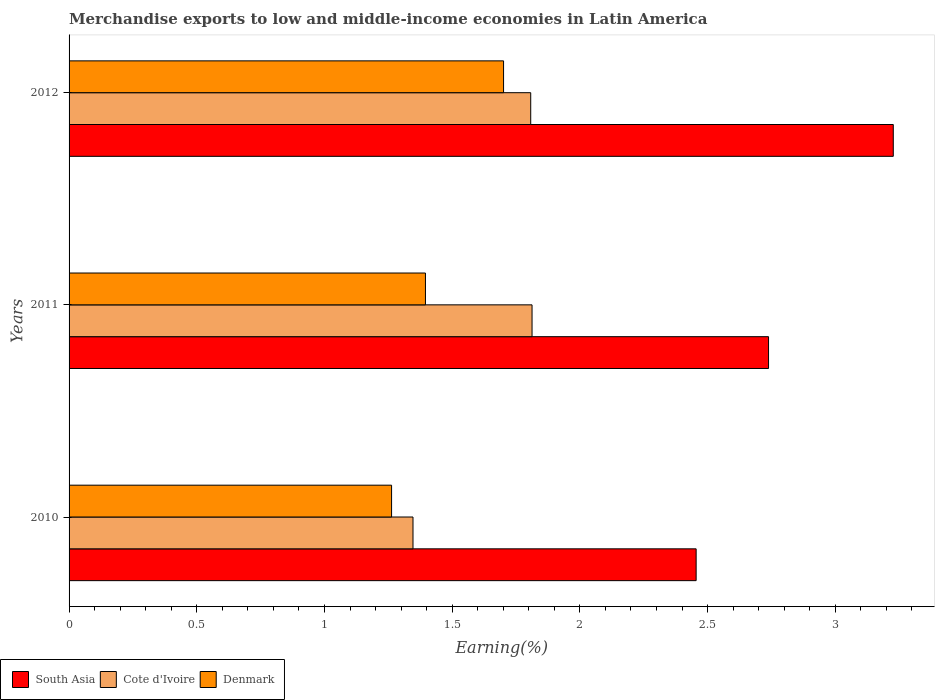How many groups of bars are there?
Your response must be concise. 3. Are the number of bars on each tick of the Y-axis equal?
Make the answer very short. Yes. How many bars are there on the 3rd tick from the top?
Provide a short and direct response. 3. How many bars are there on the 1st tick from the bottom?
Your response must be concise. 3. What is the percentage of amount earned from merchandise exports in South Asia in 2011?
Offer a terse response. 2.74. Across all years, what is the maximum percentage of amount earned from merchandise exports in South Asia?
Offer a terse response. 3.23. Across all years, what is the minimum percentage of amount earned from merchandise exports in Denmark?
Your response must be concise. 1.26. In which year was the percentage of amount earned from merchandise exports in South Asia maximum?
Your answer should be compact. 2012. What is the total percentage of amount earned from merchandise exports in Cote d'Ivoire in the graph?
Offer a terse response. 4.97. What is the difference between the percentage of amount earned from merchandise exports in South Asia in 2010 and that in 2012?
Provide a short and direct response. -0.77. What is the difference between the percentage of amount earned from merchandise exports in South Asia in 2011 and the percentage of amount earned from merchandise exports in Cote d'Ivoire in 2012?
Keep it short and to the point. 0.93. What is the average percentage of amount earned from merchandise exports in South Asia per year?
Your response must be concise. 2.81. In the year 2012, what is the difference between the percentage of amount earned from merchandise exports in Cote d'Ivoire and percentage of amount earned from merchandise exports in South Asia?
Offer a terse response. -1.42. In how many years, is the percentage of amount earned from merchandise exports in South Asia greater than 2 %?
Provide a succinct answer. 3. What is the ratio of the percentage of amount earned from merchandise exports in South Asia in 2011 to that in 2012?
Keep it short and to the point. 0.85. What is the difference between the highest and the second highest percentage of amount earned from merchandise exports in Denmark?
Your answer should be very brief. 0.31. What is the difference between the highest and the lowest percentage of amount earned from merchandise exports in South Asia?
Your answer should be very brief. 0.77. Is the sum of the percentage of amount earned from merchandise exports in Cote d'Ivoire in 2011 and 2012 greater than the maximum percentage of amount earned from merchandise exports in Denmark across all years?
Offer a terse response. Yes. What does the 1st bar from the bottom in 2011 represents?
Offer a very short reply. South Asia. Is it the case that in every year, the sum of the percentage of amount earned from merchandise exports in Denmark and percentage of amount earned from merchandise exports in South Asia is greater than the percentage of amount earned from merchandise exports in Cote d'Ivoire?
Your answer should be compact. Yes. Are all the bars in the graph horizontal?
Offer a terse response. Yes. How many years are there in the graph?
Ensure brevity in your answer.  3. Are the values on the major ticks of X-axis written in scientific E-notation?
Your answer should be very brief. No. Does the graph contain any zero values?
Provide a short and direct response. No. Does the graph contain grids?
Your response must be concise. No. What is the title of the graph?
Your answer should be very brief. Merchandise exports to low and middle-income economies in Latin America. What is the label or title of the X-axis?
Make the answer very short. Earning(%). What is the Earning(%) in South Asia in 2010?
Make the answer very short. 2.46. What is the Earning(%) in Cote d'Ivoire in 2010?
Your answer should be very brief. 1.35. What is the Earning(%) of Denmark in 2010?
Provide a short and direct response. 1.26. What is the Earning(%) in South Asia in 2011?
Provide a short and direct response. 2.74. What is the Earning(%) of Cote d'Ivoire in 2011?
Make the answer very short. 1.81. What is the Earning(%) of Denmark in 2011?
Your response must be concise. 1.4. What is the Earning(%) of South Asia in 2012?
Your answer should be very brief. 3.23. What is the Earning(%) of Cote d'Ivoire in 2012?
Your response must be concise. 1.81. What is the Earning(%) of Denmark in 2012?
Offer a terse response. 1.7. Across all years, what is the maximum Earning(%) of South Asia?
Provide a short and direct response. 3.23. Across all years, what is the maximum Earning(%) of Cote d'Ivoire?
Ensure brevity in your answer.  1.81. Across all years, what is the maximum Earning(%) in Denmark?
Keep it short and to the point. 1.7. Across all years, what is the minimum Earning(%) in South Asia?
Make the answer very short. 2.46. Across all years, what is the minimum Earning(%) in Cote d'Ivoire?
Provide a short and direct response. 1.35. Across all years, what is the minimum Earning(%) in Denmark?
Ensure brevity in your answer.  1.26. What is the total Earning(%) of South Asia in the graph?
Your answer should be very brief. 8.42. What is the total Earning(%) of Cote d'Ivoire in the graph?
Your answer should be very brief. 4.97. What is the total Earning(%) in Denmark in the graph?
Provide a short and direct response. 4.36. What is the difference between the Earning(%) of South Asia in 2010 and that in 2011?
Offer a terse response. -0.28. What is the difference between the Earning(%) in Cote d'Ivoire in 2010 and that in 2011?
Offer a very short reply. -0.47. What is the difference between the Earning(%) in Denmark in 2010 and that in 2011?
Provide a short and direct response. -0.13. What is the difference between the Earning(%) in South Asia in 2010 and that in 2012?
Make the answer very short. -0.77. What is the difference between the Earning(%) of Cote d'Ivoire in 2010 and that in 2012?
Offer a terse response. -0.46. What is the difference between the Earning(%) of Denmark in 2010 and that in 2012?
Keep it short and to the point. -0.44. What is the difference between the Earning(%) in South Asia in 2011 and that in 2012?
Your response must be concise. -0.49. What is the difference between the Earning(%) of Cote d'Ivoire in 2011 and that in 2012?
Your response must be concise. 0.01. What is the difference between the Earning(%) in Denmark in 2011 and that in 2012?
Provide a succinct answer. -0.31. What is the difference between the Earning(%) of South Asia in 2010 and the Earning(%) of Cote d'Ivoire in 2011?
Provide a succinct answer. 0.64. What is the difference between the Earning(%) of South Asia in 2010 and the Earning(%) of Denmark in 2011?
Your answer should be compact. 1.06. What is the difference between the Earning(%) of Cote d'Ivoire in 2010 and the Earning(%) of Denmark in 2011?
Offer a terse response. -0.05. What is the difference between the Earning(%) of South Asia in 2010 and the Earning(%) of Cote d'Ivoire in 2012?
Keep it short and to the point. 0.65. What is the difference between the Earning(%) of South Asia in 2010 and the Earning(%) of Denmark in 2012?
Your answer should be compact. 0.75. What is the difference between the Earning(%) in Cote d'Ivoire in 2010 and the Earning(%) in Denmark in 2012?
Offer a very short reply. -0.35. What is the difference between the Earning(%) of South Asia in 2011 and the Earning(%) of Cote d'Ivoire in 2012?
Offer a very short reply. 0.93. What is the difference between the Earning(%) of South Asia in 2011 and the Earning(%) of Denmark in 2012?
Your answer should be very brief. 1.04. What is the difference between the Earning(%) of Cote d'Ivoire in 2011 and the Earning(%) of Denmark in 2012?
Provide a succinct answer. 0.11. What is the average Earning(%) in South Asia per year?
Give a very brief answer. 2.81. What is the average Earning(%) in Cote d'Ivoire per year?
Your answer should be very brief. 1.66. What is the average Earning(%) of Denmark per year?
Your response must be concise. 1.45. In the year 2010, what is the difference between the Earning(%) in South Asia and Earning(%) in Cote d'Ivoire?
Offer a terse response. 1.11. In the year 2010, what is the difference between the Earning(%) in South Asia and Earning(%) in Denmark?
Provide a short and direct response. 1.19. In the year 2010, what is the difference between the Earning(%) in Cote d'Ivoire and Earning(%) in Denmark?
Provide a short and direct response. 0.08. In the year 2011, what is the difference between the Earning(%) of South Asia and Earning(%) of Cote d'Ivoire?
Keep it short and to the point. 0.93. In the year 2011, what is the difference between the Earning(%) in South Asia and Earning(%) in Denmark?
Your response must be concise. 1.34. In the year 2011, what is the difference between the Earning(%) in Cote d'Ivoire and Earning(%) in Denmark?
Your answer should be compact. 0.42. In the year 2012, what is the difference between the Earning(%) of South Asia and Earning(%) of Cote d'Ivoire?
Your response must be concise. 1.42. In the year 2012, what is the difference between the Earning(%) of South Asia and Earning(%) of Denmark?
Provide a short and direct response. 1.53. In the year 2012, what is the difference between the Earning(%) in Cote d'Ivoire and Earning(%) in Denmark?
Give a very brief answer. 0.11. What is the ratio of the Earning(%) of South Asia in 2010 to that in 2011?
Make the answer very short. 0.9. What is the ratio of the Earning(%) in Cote d'Ivoire in 2010 to that in 2011?
Keep it short and to the point. 0.74. What is the ratio of the Earning(%) in Denmark in 2010 to that in 2011?
Provide a succinct answer. 0.91. What is the ratio of the Earning(%) of South Asia in 2010 to that in 2012?
Offer a very short reply. 0.76. What is the ratio of the Earning(%) in Cote d'Ivoire in 2010 to that in 2012?
Your answer should be very brief. 0.74. What is the ratio of the Earning(%) in Denmark in 2010 to that in 2012?
Your response must be concise. 0.74. What is the ratio of the Earning(%) of South Asia in 2011 to that in 2012?
Offer a very short reply. 0.85. What is the ratio of the Earning(%) of Cote d'Ivoire in 2011 to that in 2012?
Keep it short and to the point. 1. What is the ratio of the Earning(%) of Denmark in 2011 to that in 2012?
Your answer should be compact. 0.82. What is the difference between the highest and the second highest Earning(%) of South Asia?
Offer a terse response. 0.49. What is the difference between the highest and the second highest Earning(%) of Cote d'Ivoire?
Give a very brief answer. 0.01. What is the difference between the highest and the second highest Earning(%) of Denmark?
Make the answer very short. 0.31. What is the difference between the highest and the lowest Earning(%) of South Asia?
Provide a succinct answer. 0.77. What is the difference between the highest and the lowest Earning(%) in Cote d'Ivoire?
Ensure brevity in your answer.  0.47. What is the difference between the highest and the lowest Earning(%) in Denmark?
Offer a terse response. 0.44. 